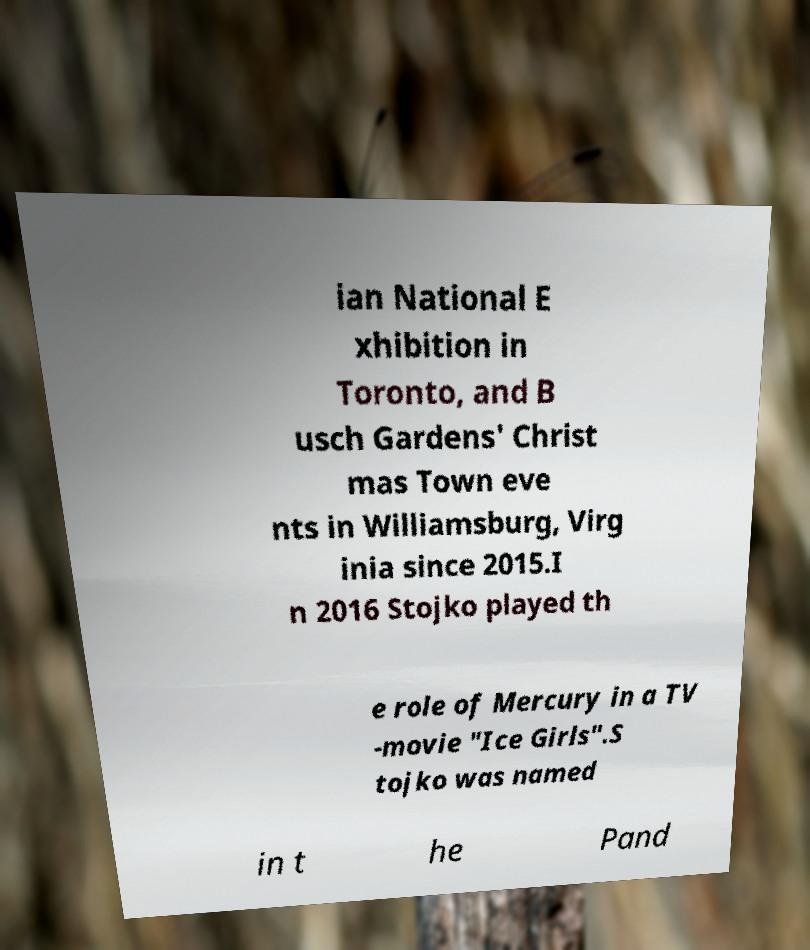Can you read and provide the text displayed in the image?This photo seems to have some interesting text. Can you extract and type it out for me? ian National E xhibition in Toronto, and B usch Gardens' Christ mas Town eve nts in Williamsburg, Virg inia since 2015.I n 2016 Stojko played th e role of Mercury in a TV -movie "Ice Girls".S tojko was named in t he Pand 